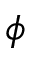Convert formula to latex. <formula><loc_0><loc_0><loc_500><loc_500>\phi</formula> 